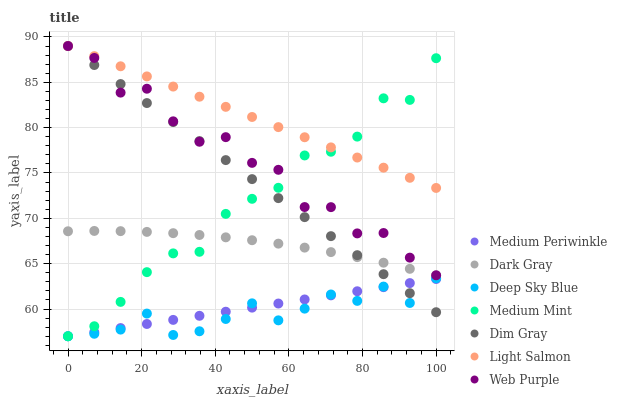Does Deep Sky Blue have the minimum area under the curve?
Answer yes or no. Yes. Does Light Salmon have the maximum area under the curve?
Answer yes or no. Yes. Does Dim Gray have the minimum area under the curve?
Answer yes or no. No. Does Dim Gray have the maximum area under the curve?
Answer yes or no. No. Is Dim Gray the smoothest?
Answer yes or no. Yes. Is Web Purple the roughest?
Answer yes or no. Yes. Is Light Salmon the smoothest?
Answer yes or no. No. Is Light Salmon the roughest?
Answer yes or no. No. Does Medium Mint have the lowest value?
Answer yes or no. Yes. Does Dim Gray have the lowest value?
Answer yes or no. No. Does Web Purple have the highest value?
Answer yes or no. Yes. Does Medium Periwinkle have the highest value?
Answer yes or no. No. Is Deep Sky Blue less than Web Purple?
Answer yes or no. Yes. Is Dark Gray greater than Deep Sky Blue?
Answer yes or no. Yes. Does Web Purple intersect Medium Mint?
Answer yes or no. Yes. Is Web Purple less than Medium Mint?
Answer yes or no. No. Is Web Purple greater than Medium Mint?
Answer yes or no. No. Does Deep Sky Blue intersect Web Purple?
Answer yes or no. No. 